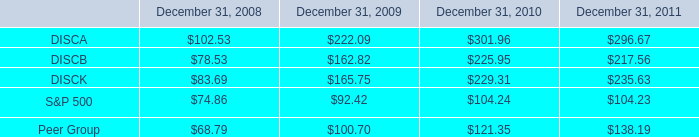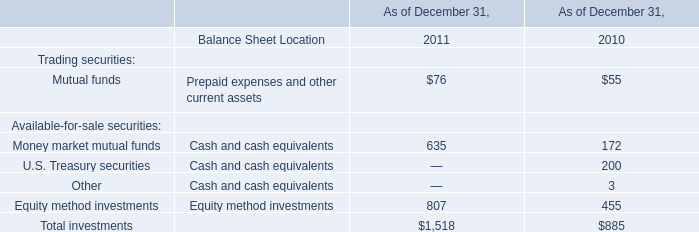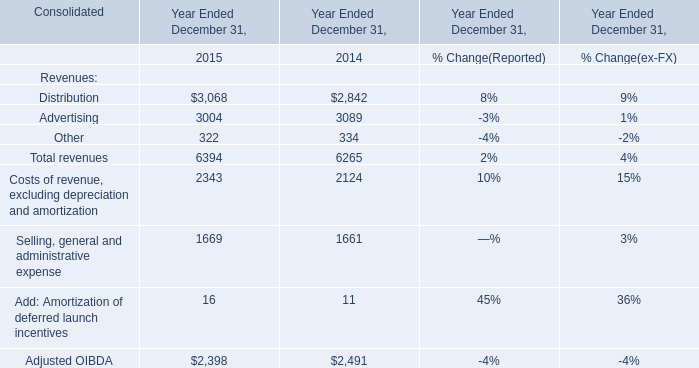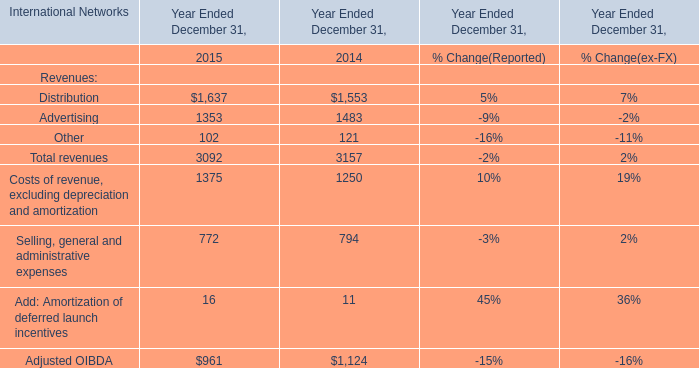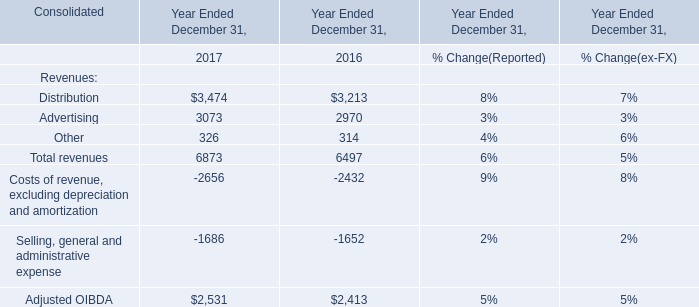what was the percentage cumulative total shareholder return on disca from september 18 , 2008 to december 31 , 2011? 
Computations: ((296.67 - 100) / 100)
Answer: 1.9667. 